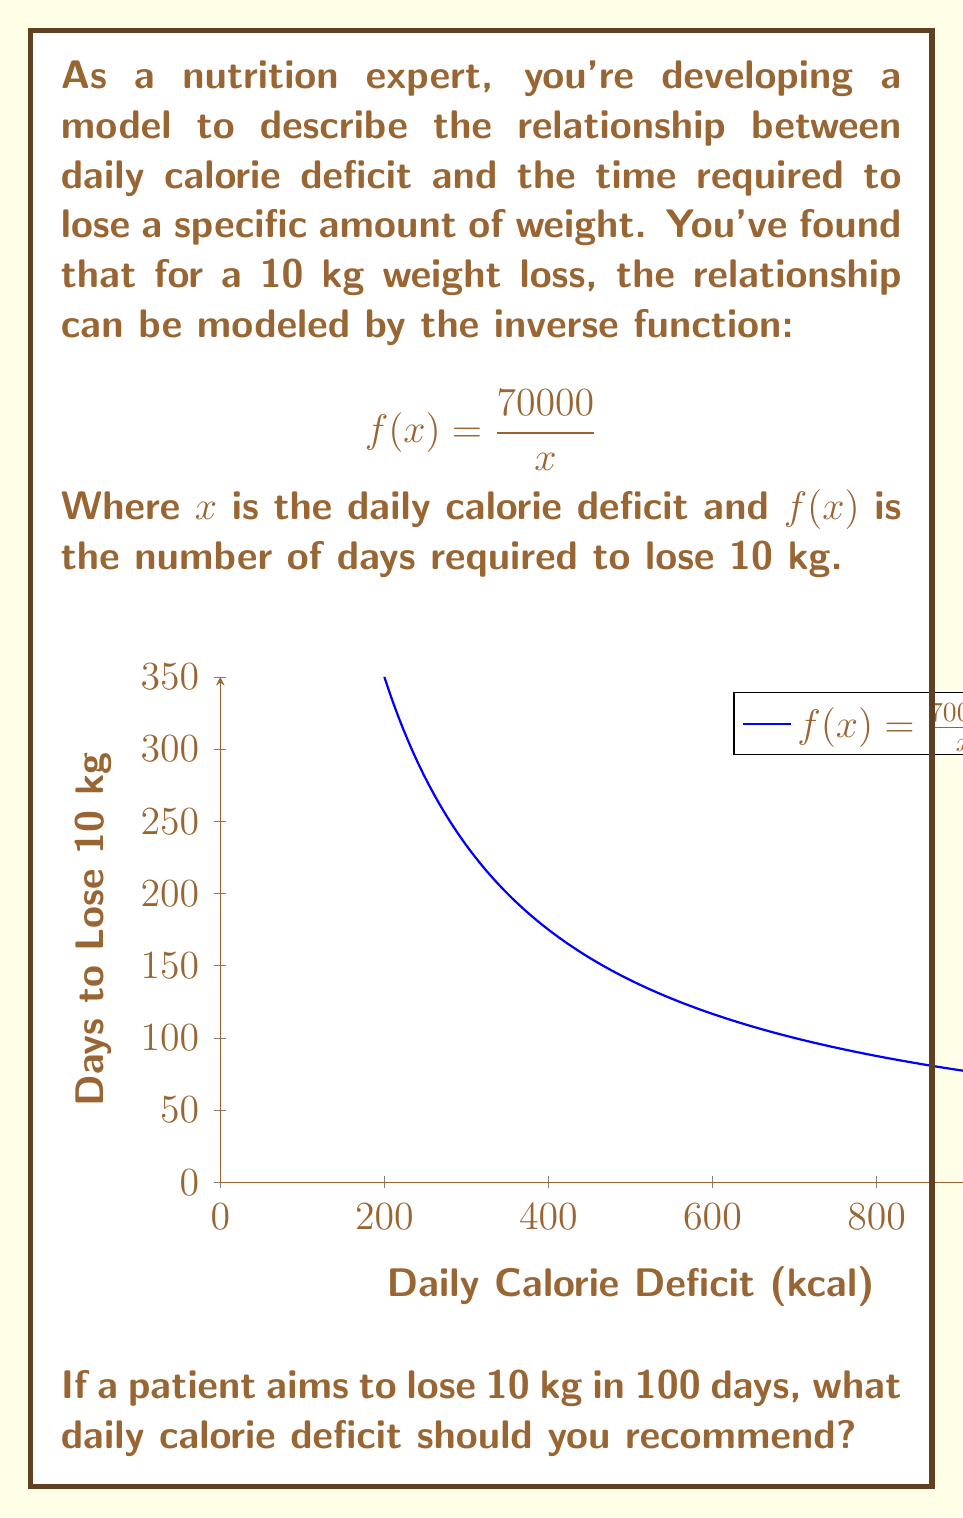Could you help me with this problem? To solve this problem, we need to use the given inverse function and find the value of $x$ when $f(x) = 100$. Let's approach this step-by-step:

1) We start with the function: $f(x) = \frac{70000}{x}$

2) We want to find $x$ when $f(x) = 100$, so we set up the equation:

   $100 = \frac{70000}{x}$

3) To solve for $x$, we multiply both sides by $x$:

   $100x = 70000$

4) Now, we divide both sides by 100:

   $x = \frac{70000}{100}$

5) Simplify:

   $x = 700$

This means that to lose 10 kg in 100 days, the patient needs a daily calorie deficit of 700 kcal.

To verify, we can plug this back into the original function:

$f(700) = \frac{70000}{700} = 100$ days

This confirms our solution is correct.
Answer: 700 kcal 